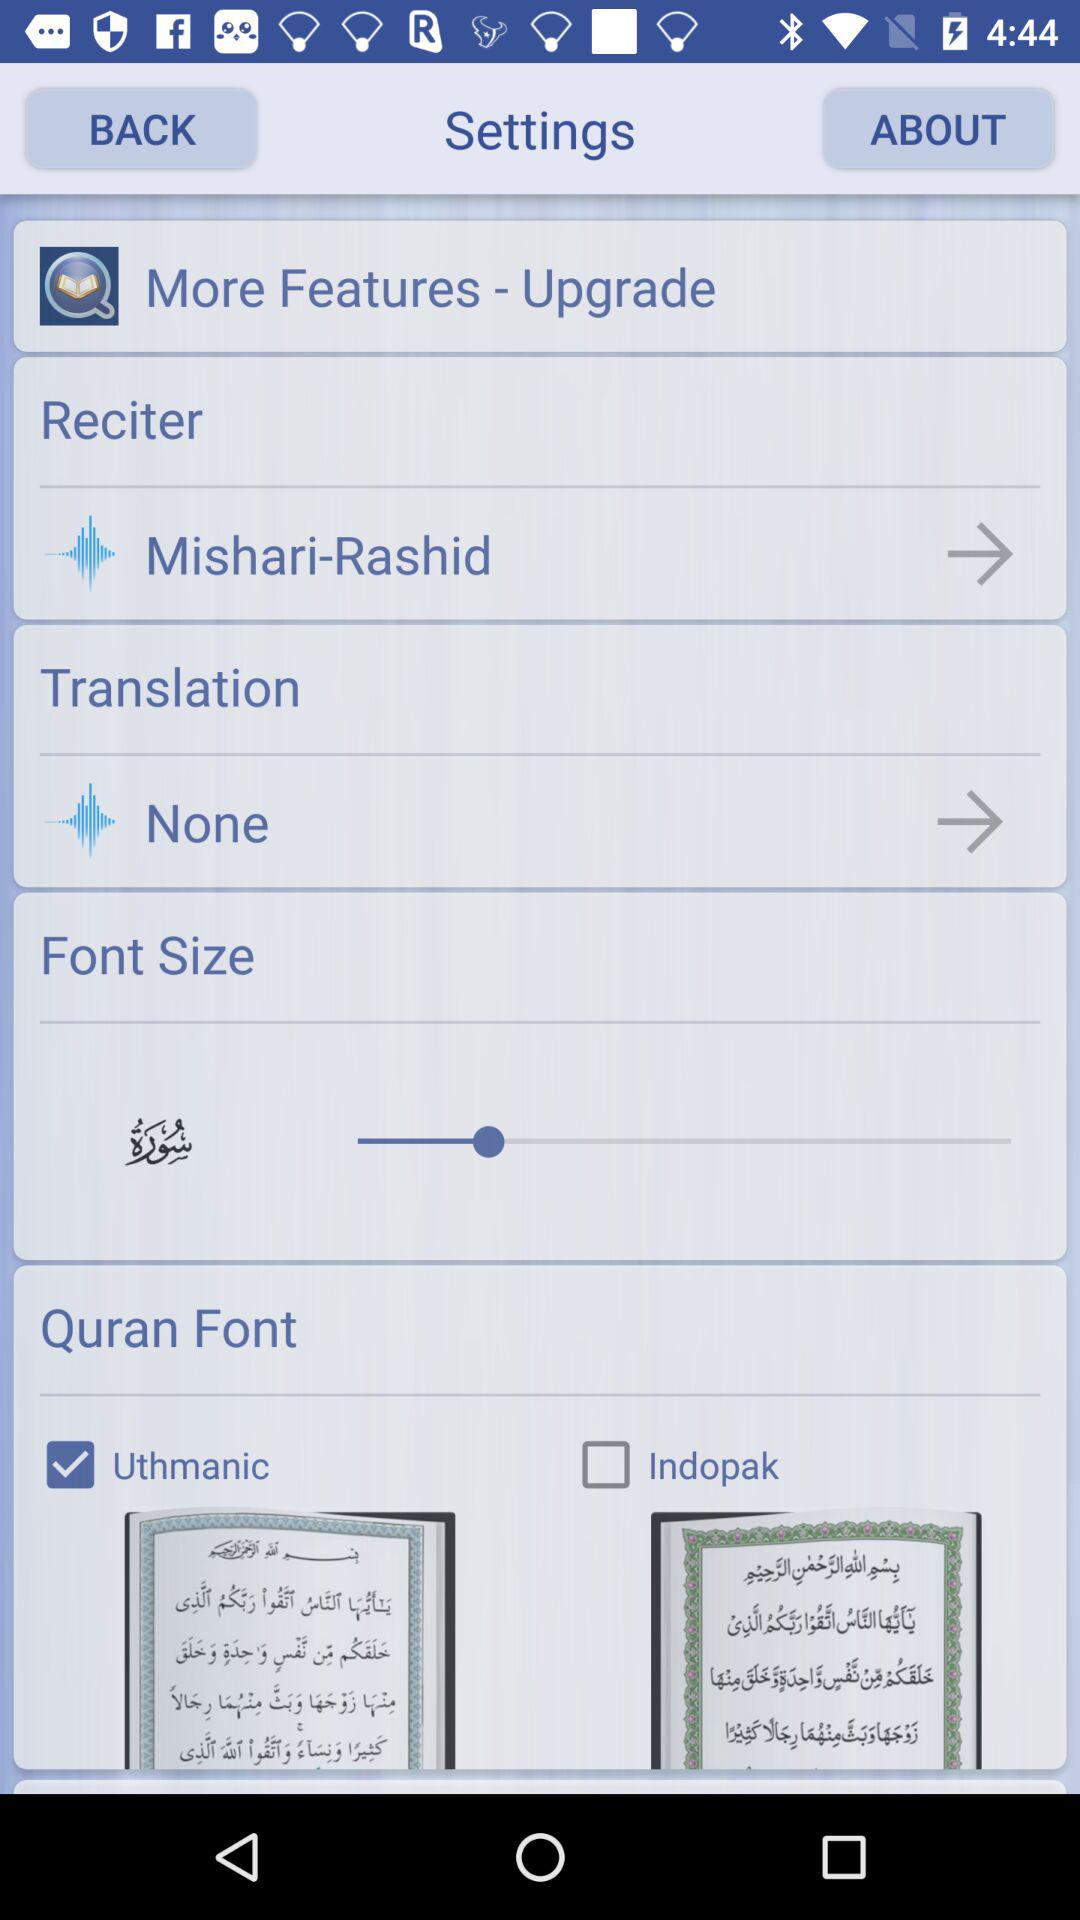How many checkboxes are in the settings menu?
Answer the question using a single word or phrase. 2 